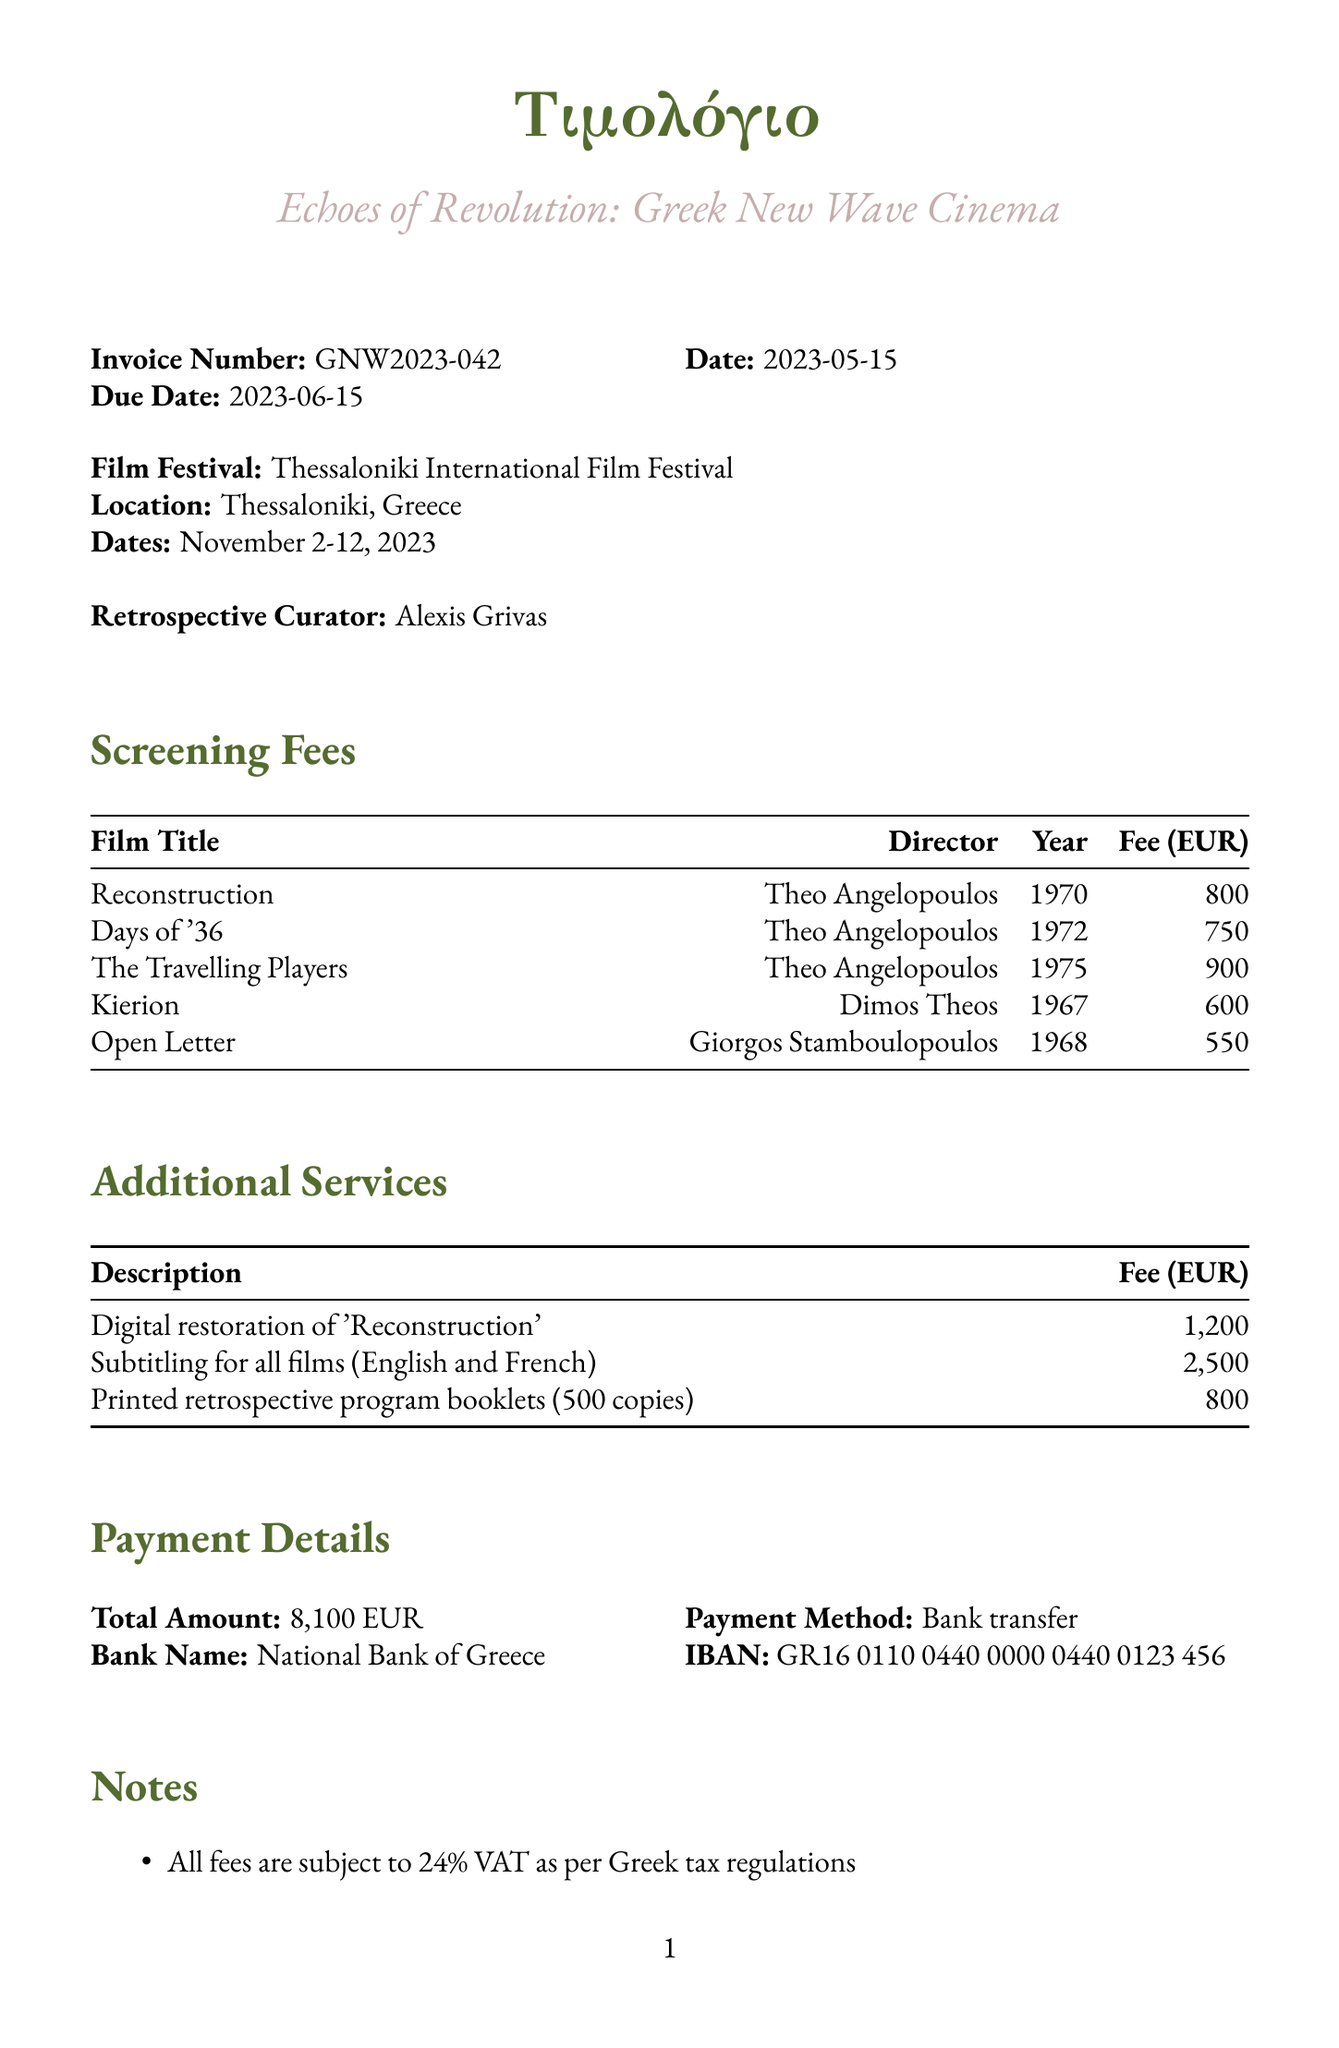What is the invoice number? The invoice number is explicitly stated in the document and allows for reference.
Answer: GNW2023-042 Who is the retrospective curator? The curator's name is provided in the document, indicating who is responsible for the retrospective.
Answer: Alexis Grivas What is the total amount due? The total amount is a critical component of an invoice, summarizing all fees and charges.
Answer: 8100 EUR Which film has the highest screening fee? Comparing the fees of the films listed will show which film costs the most to screen.
Answer: The Travelling Players When is the due date for the invoice? The due date is important for payment planning and is included in the invoice details.
Answer: 2023-06-15 What additional service costs the most? The costs for additional services give insight into the extras for the film festival.
Answer: Subtitling for all films (English and French) How many copies of the retrospective program booklets are printed? The number of printed copies is relevant to understanding the scale of the event.
Answer: 500 copies What is the payment method specified? The payment method is crucial for understanding how to settle the invoice.
Answer: Bank transfer What is the VAT percentage applied to the fees? Knowing the VAT percentage helps in understanding the total cost implications.
Answer: 24% 